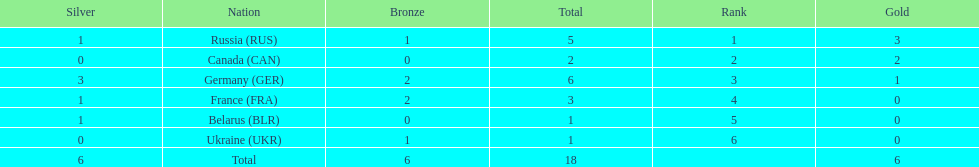Who had a larger total medal count, france or canada? France. 